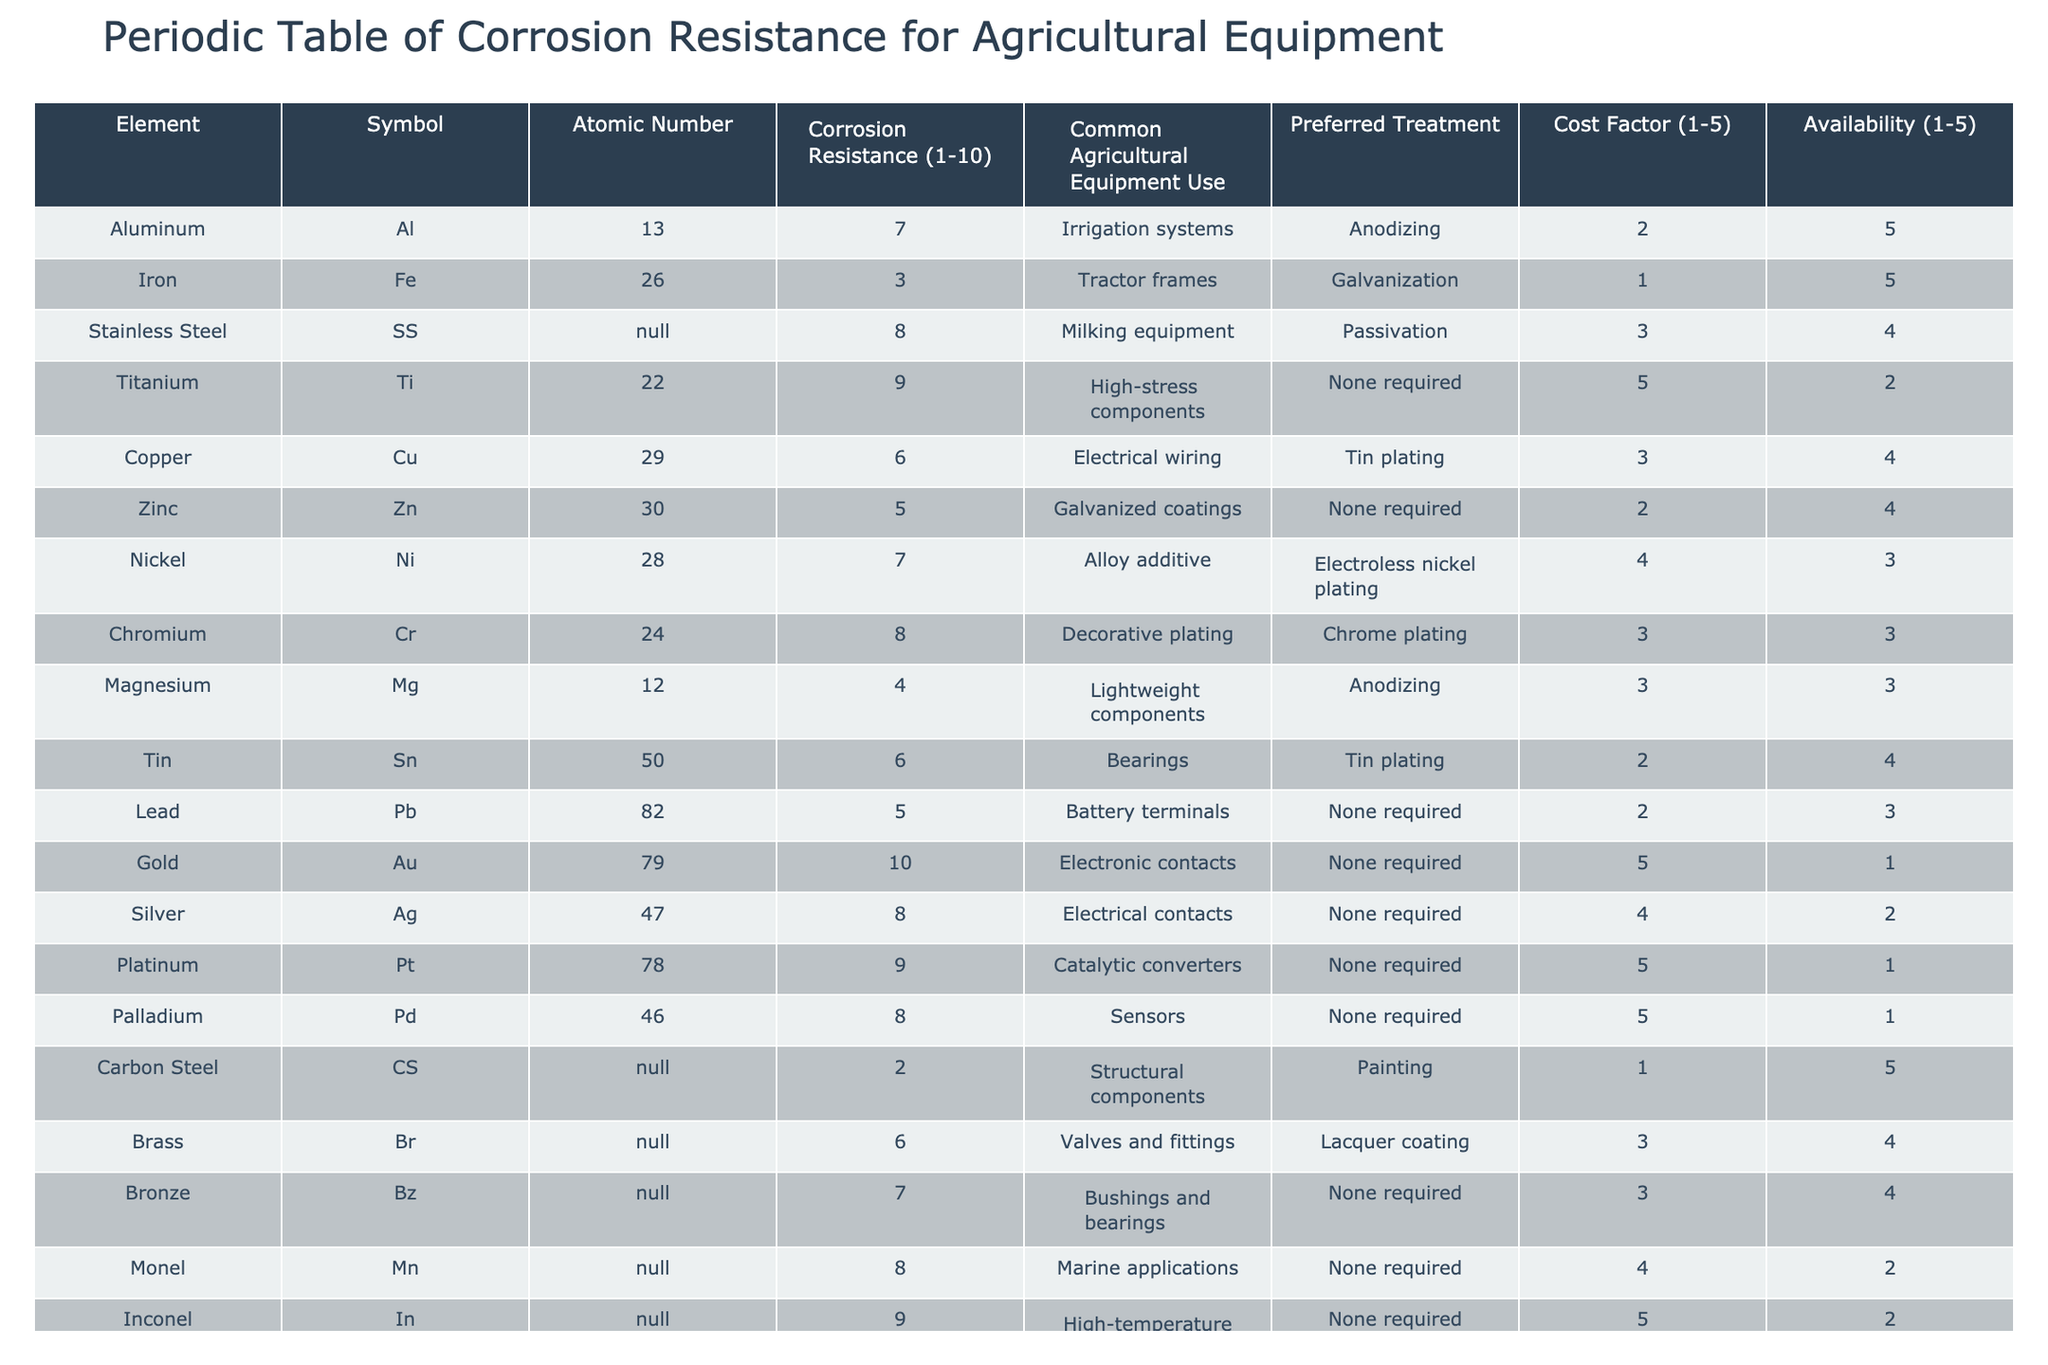What is the corrosion resistance rating of Titanium? The corrosion resistance rating is provided directly in the table under the "Corrosion Resistance" column for Titanium (Ti), which indicates a value of 9.
Answer: 9 Which material has the lowest corrosion resistance rating, and what is its rating? By scanning the "Corrosion Resistance" column, Carbon Steel (CS) is identified as the material with the lowest rating of 2.
Answer: Carbon Steel, 2 Is Stainless Steel commonly used for high-stress components? The table lists Stainless Steel (SS) and shows its common agricultural equipment use is milking equipment, which does not classify it as high-stress components. Therefore, the answer is no.
Answer: No What is the average corrosion resistance rating of all metals used in agricultural equipment? The ratings sum to 63 (7 + 3 + 8 + 9 + 6 + 5 + 7 + 8 + 4 + 6 + 5 + 10 + 8 + 9 + 8 + 2 + 6 + 7 + 8 + 9), with 20 entries. Hence, the average is 63/20 = 3.15.
Answer: 3.15 Do all metals used in agricultural equipment have a cost factor greater than 1? By examining the "Cost Factor" column, Carbon Steel (CS), Iron (Fe), Lead (Pb), and Zinc (Zn) each have a cost factor of 1 or lower. Thus, the statement is false.
Answer: No Which two materials used for agricultural equipment have a corrosion resistance rating of 8? Importing the data from the table for the "Corrosion Resistance" rating of 8 indicates that Stainless Steel (SS) and Chromium (Cr) both share this rating.
Answer: Stainless Steel, Chromium What materials require no treatment, and what is their corrosion resistance rating? The table shows both Zinc (Zn) and Lead (Pb) have a rating of 5, while several other materials such as Gold (Au), Silver (Ag), Platinum (Pt), Palladium (Pd), and Bronze (Bz) also require no treatment. The ratings for these are 10, 8, 9, 8, and 7 respectively.
Answer: Gold (10), Silver (8), Platinum (9), Palladium (8), Bronze (7) What is the difference in corrosion resistance rating between Titanium and Aluminum? Titanium has a rating of 9 and Aluminum has a rating of 7. The difference is computed as 9 - 7 = 2.
Answer: 2 Which metal has the highest corrosion resistance rating, and what is its use? The metals listed indicate Gold (Au) has the highest corrosion resistance rating of 10, and it is commonly used for electronic contacts.
Answer: Gold, electronic contacts 